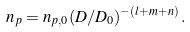<formula> <loc_0><loc_0><loc_500><loc_500>n _ { p } = n _ { p , 0 } ( D / D _ { 0 } ) ^ { - ( l + m + n ) } \, .</formula> 